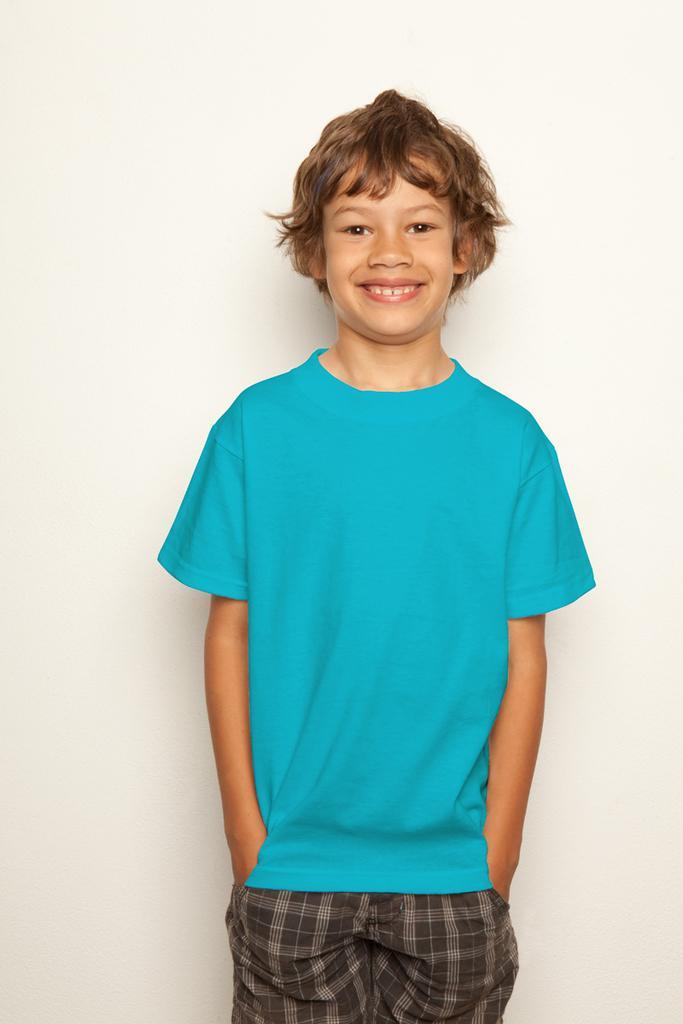How would you summarize this image in a sentence or two? In this image, we can see a person. We can also see the background. 